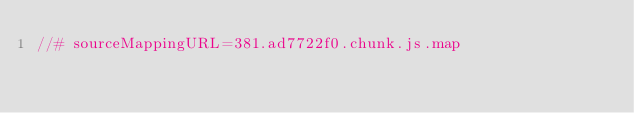<code> <loc_0><loc_0><loc_500><loc_500><_JavaScript_>//# sourceMappingURL=381.ad7722f0.chunk.js.map</code> 